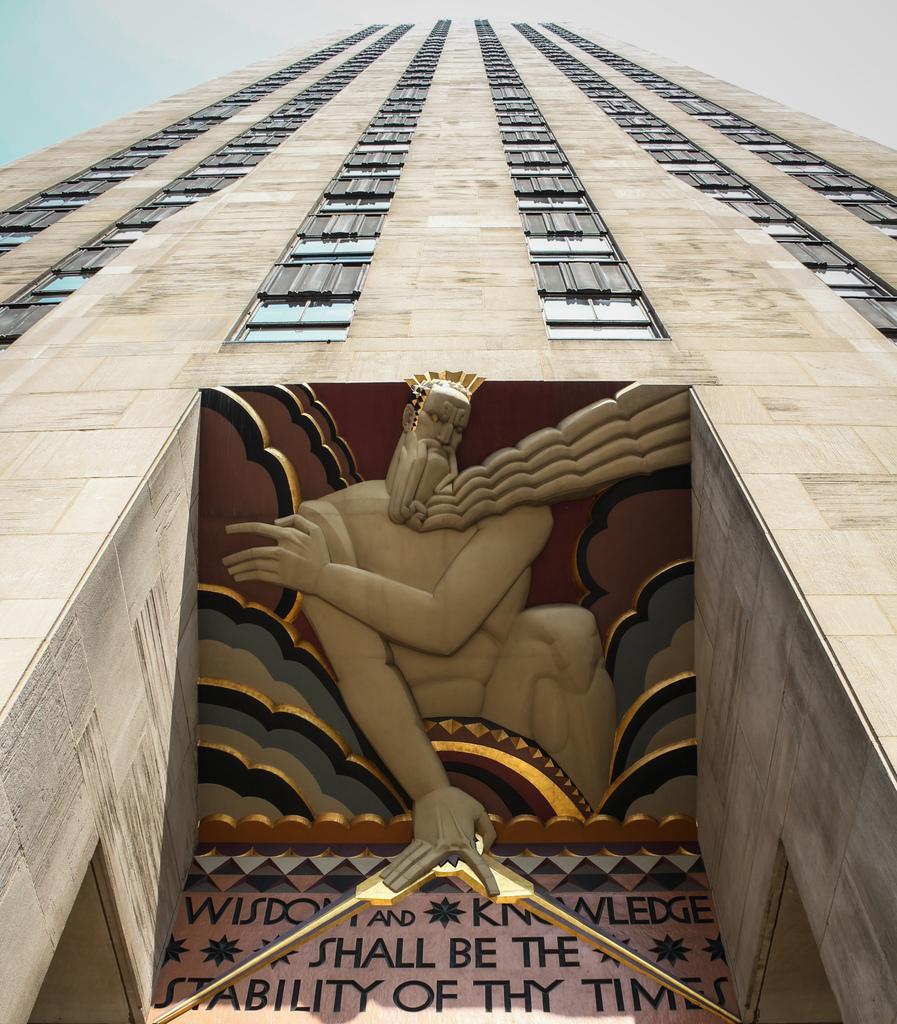Describe this image in one or two sentences. In this picture we can see a building and few windows, and also we can find text on the building. 